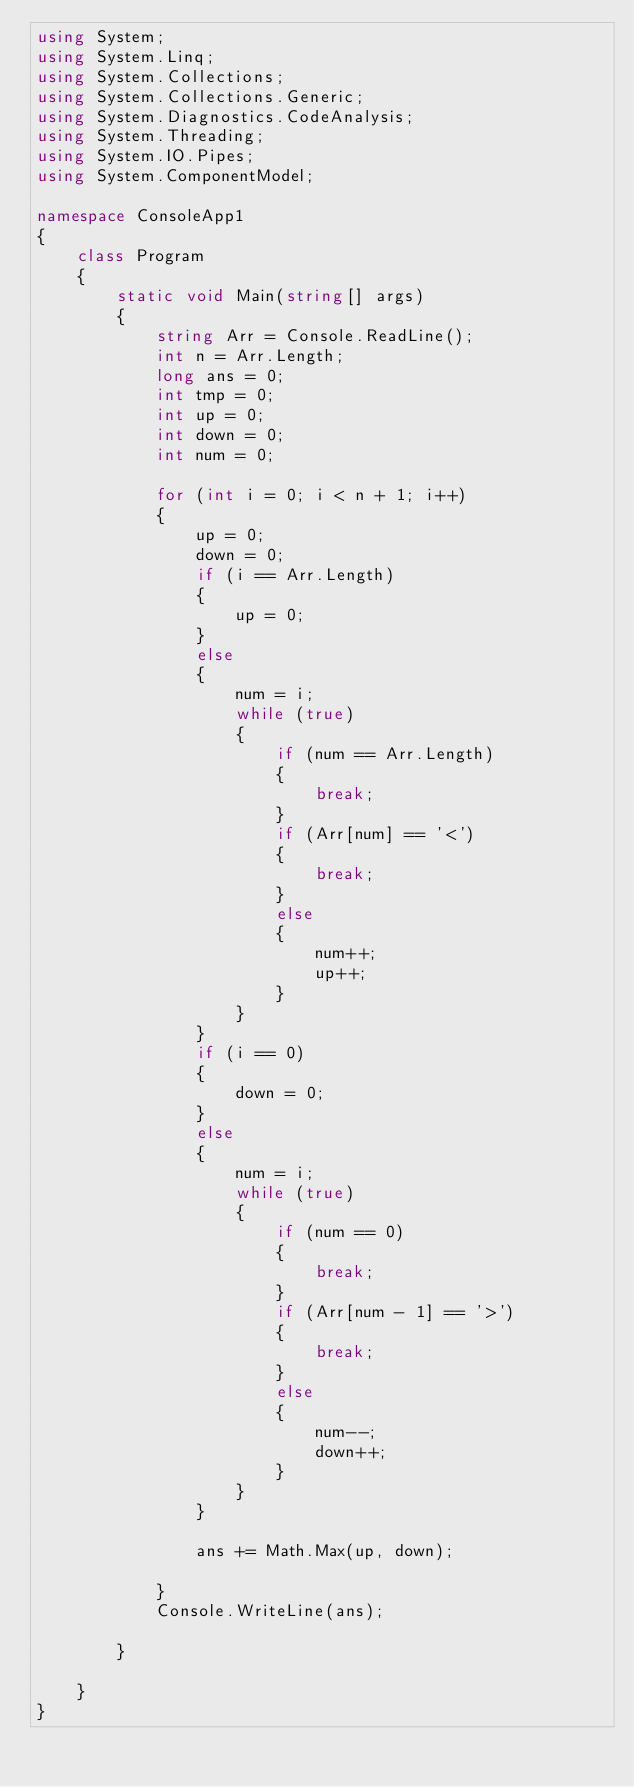Convert code to text. <code><loc_0><loc_0><loc_500><loc_500><_C#_>using System;
using System.Linq;
using System.Collections;
using System.Collections.Generic;
using System.Diagnostics.CodeAnalysis;
using System.Threading;
using System.IO.Pipes;
using System.ComponentModel;

namespace ConsoleApp1
{
    class Program
    {
        static void Main(string[] args)
        {
            string Arr = Console.ReadLine();
            int n = Arr.Length;
            long ans = 0;
            int tmp = 0;
            int up = 0;
            int down = 0;
            int num = 0;

            for (int i = 0; i < n + 1; i++) 
            {
                up = 0;
                down = 0;
                if (i == Arr.Length)
                {
                    up = 0;
                }
                else
                {
                    num = i;
                    while (true)
                    {
                        if (num == Arr.Length)
                        {
                            break;
                        }
                        if (Arr[num] == '<')
                        {
                            break;
                        }
                        else
                        {
                            num++;
                            up++;
                        }
                    }
                }
                if (i == 0)
                {
                    down = 0;
                }
                else
                {
                    num = i;
                    while (true)
                    {
                        if (num == 0)
                        {
                            break;
                        }
                        if (Arr[num - 1] == '>')
                        {
                            break;
                        }
                        else
                        {
                            num--;
                            down++;
                        }
                    }
                }

                ans += Math.Max(up, down); 

            }
            Console.WriteLine(ans);

        }

    }
}
</code> 